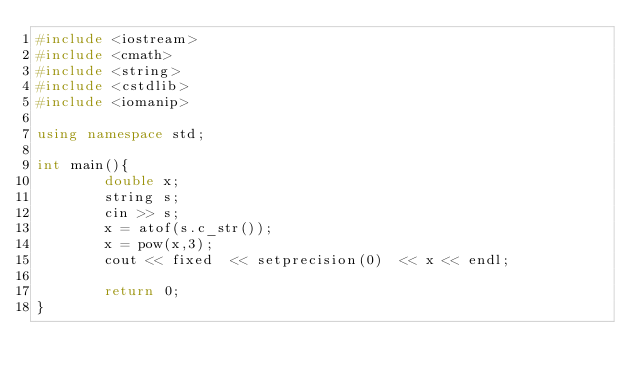Convert code to text. <code><loc_0><loc_0><loc_500><loc_500><_C++_>#include <iostream>
#include <cmath>
#include <string>
#include <cstdlib>
#include <iomanip>

using namespace std;

int main(){
        double x;
        string s;
        cin >> s;
        x = atof(s.c_str());
        x = pow(x,3);
        cout << fixed  << setprecision(0)  << x << endl;

        return 0;
}
</code> 